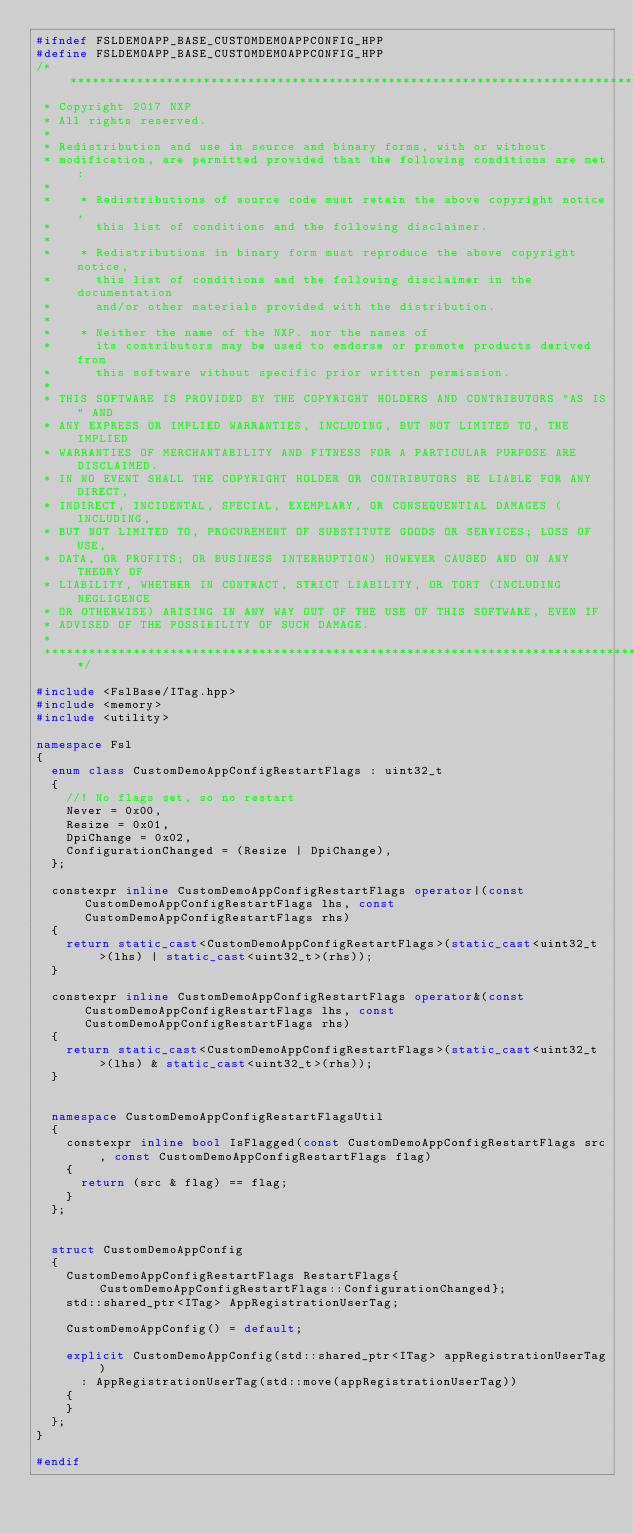Convert code to text. <code><loc_0><loc_0><loc_500><loc_500><_C++_>#ifndef FSLDEMOAPP_BASE_CUSTOMDEMOAPPCONFIG_HPP
#define FSLDEMOAPP_BASE_CUSTOMDEMOAPPCONFIG_HPP
/****************************************************************************************************************************************************
 * Copyright 2017 NXP
 * All rights reserved.
 *
 * Redistribution and use in source and binary forms, with or without
 * modification, are permitted provided that the following conditions are met:
 *
 *    * Redistributions of source code must retain the above copyright notice,
 *      this list of conditions and the following disclaimer.
 *
 *    * Redistributions in binary form must reproduce the above copyright notice,
 *      this list of conditions and the following disclaimer in the documentation
 *      and/or other materials provided with the distribution.
 *
 *    * Neither the name of the NXP. nor the names of
 *      its contributors may be used to endorse or promote products derived from
 *      this software without specific prior written permission.
 *
 * THIS SOFTWARE IS PROVIDED BY THE COPYRIGHT HOLDERS AND CONTRIBUTORS "AS IS" AND
 * ANY EXPRESS OR IMPLIED WARRANTIES, INCLUDING, BUT NOT LIMITED TO, THE IMPLIED
 * WARRANTIES OF MERCHANTABILITY AND FITNESS FOR A PARTICULAR PURPOSE ARE DISCLAIMED.
 * IN NO EVENT SHALL THE COPYRIGHT HOLDER OR CONTRIBUTORS BE LIABLE FOR ANY DIRECT,
 * INDIRECT, INCIDENTAL, SPECIAL, EXEMPLARY, OR CONSEQUENTIAL DAMAGES (INCLUDING,
 * BUT NOT LIMITED TO, PROCUREMENT OF SUBSTITUTE GOODS OR SERVICES; LOSS OF USE,
 * DATA, OR PROFITS; OR BUSINESS INTERRUPTION) HOWEVER CAUSED AND ON ANY THEORY OF
 * LIABILITY, WHETHER IN CONTRACT, STRICT LIABILITY, OR TORT (INCLUDING NEGLIGENCE
 * OR OTHERWISE) ARISING IN ANY WAY OUT OF THE USE OF THIS SOFTWARE, EVEN IF
 * ADVISED OF THE POSSIBILITY OF SUCH DAMAGE.
 *
 ****************************************************************************************************************************************************/

#include <FslBase/ITag.hpp>
#include <memory>
#include <utility>

namespace Fsl
{
  enum class CustomDemoAppConfigRestartFlags : uint32_t
  {
    //! No flags set, so no restart
    Never = 0x00,
    Resize = 0x01,
    DpiChange = 0x02,
    ConfigurationChanged = (Resize | DpiChange),
  };

  constexpr inline CustomDemoAppConfigRestartFlags operator|(const CustomDemoAppConfigRestartFlags lhs, const CustomDemoAppConfigRestartFlags rhs)
  {
    return static_cast<CustomDemoAppConfigRestartFlags>(static_cast<uint32_t>(lhs) | static_cast<uint32_t>(rhs));
  }

  constexpr inline CustomDemoAppConfigRestartFlags operator&(const CustomDemoAppConfigRestartFlags lhs, const CustomDemoAppConfigRestartFlags rhs)
  {
    return static_cast<CustomDemoAppConfigRestartFlags>(static_cast<uint32_t>(lhs) & static_cast<uint32_t>(rhs));
  }


  namespace CustomDemoAppConfigRestartFlagsUtil
  {
    constexpr inline bool IsFlagged(const CustomDemoAppConfigRestartFlags src, const CustomDemoAppConfigRestartFlags flag)
    {
      return (src & flag) == flag;
    }
  };


  struct CustomDemoAppConfig
  {
    CustomDemoAppConfigRestartFlags RestartFlags{CustomDemoAppConfigRestartFlags::ConfigurationChanged};
    std::shared_ptr<ITag> AppRegistrationUserTag;

    CustomDemoAppConfig() = default;

    explicit CustomDemoAppConfig(std::shared_ptr<ITag> appRegistrationUserTag)
      : AppRegistrationUserTag(std::move(appRegistrationUserTag))
    {
    }
  };
}

#endif
</code> 